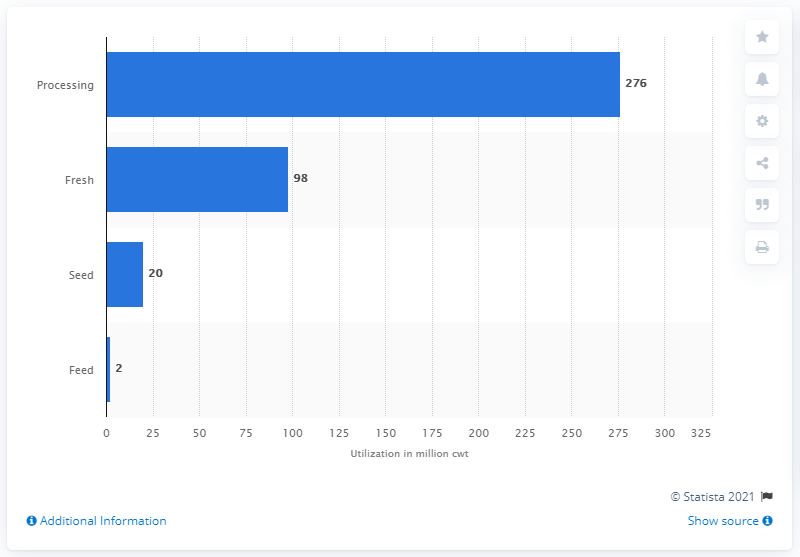Indicate a few pertinent items in this graphic. The highest amount of potato utilization in the US in 2019 was for processing, which amounted to approximately 1,200 million cwt. The sum of potato utilization for fresh and seed in the US in 2019 was approximately 118 million cwt. In 2019, the United States sold approximately 276 thousand cwt of potatoes. 